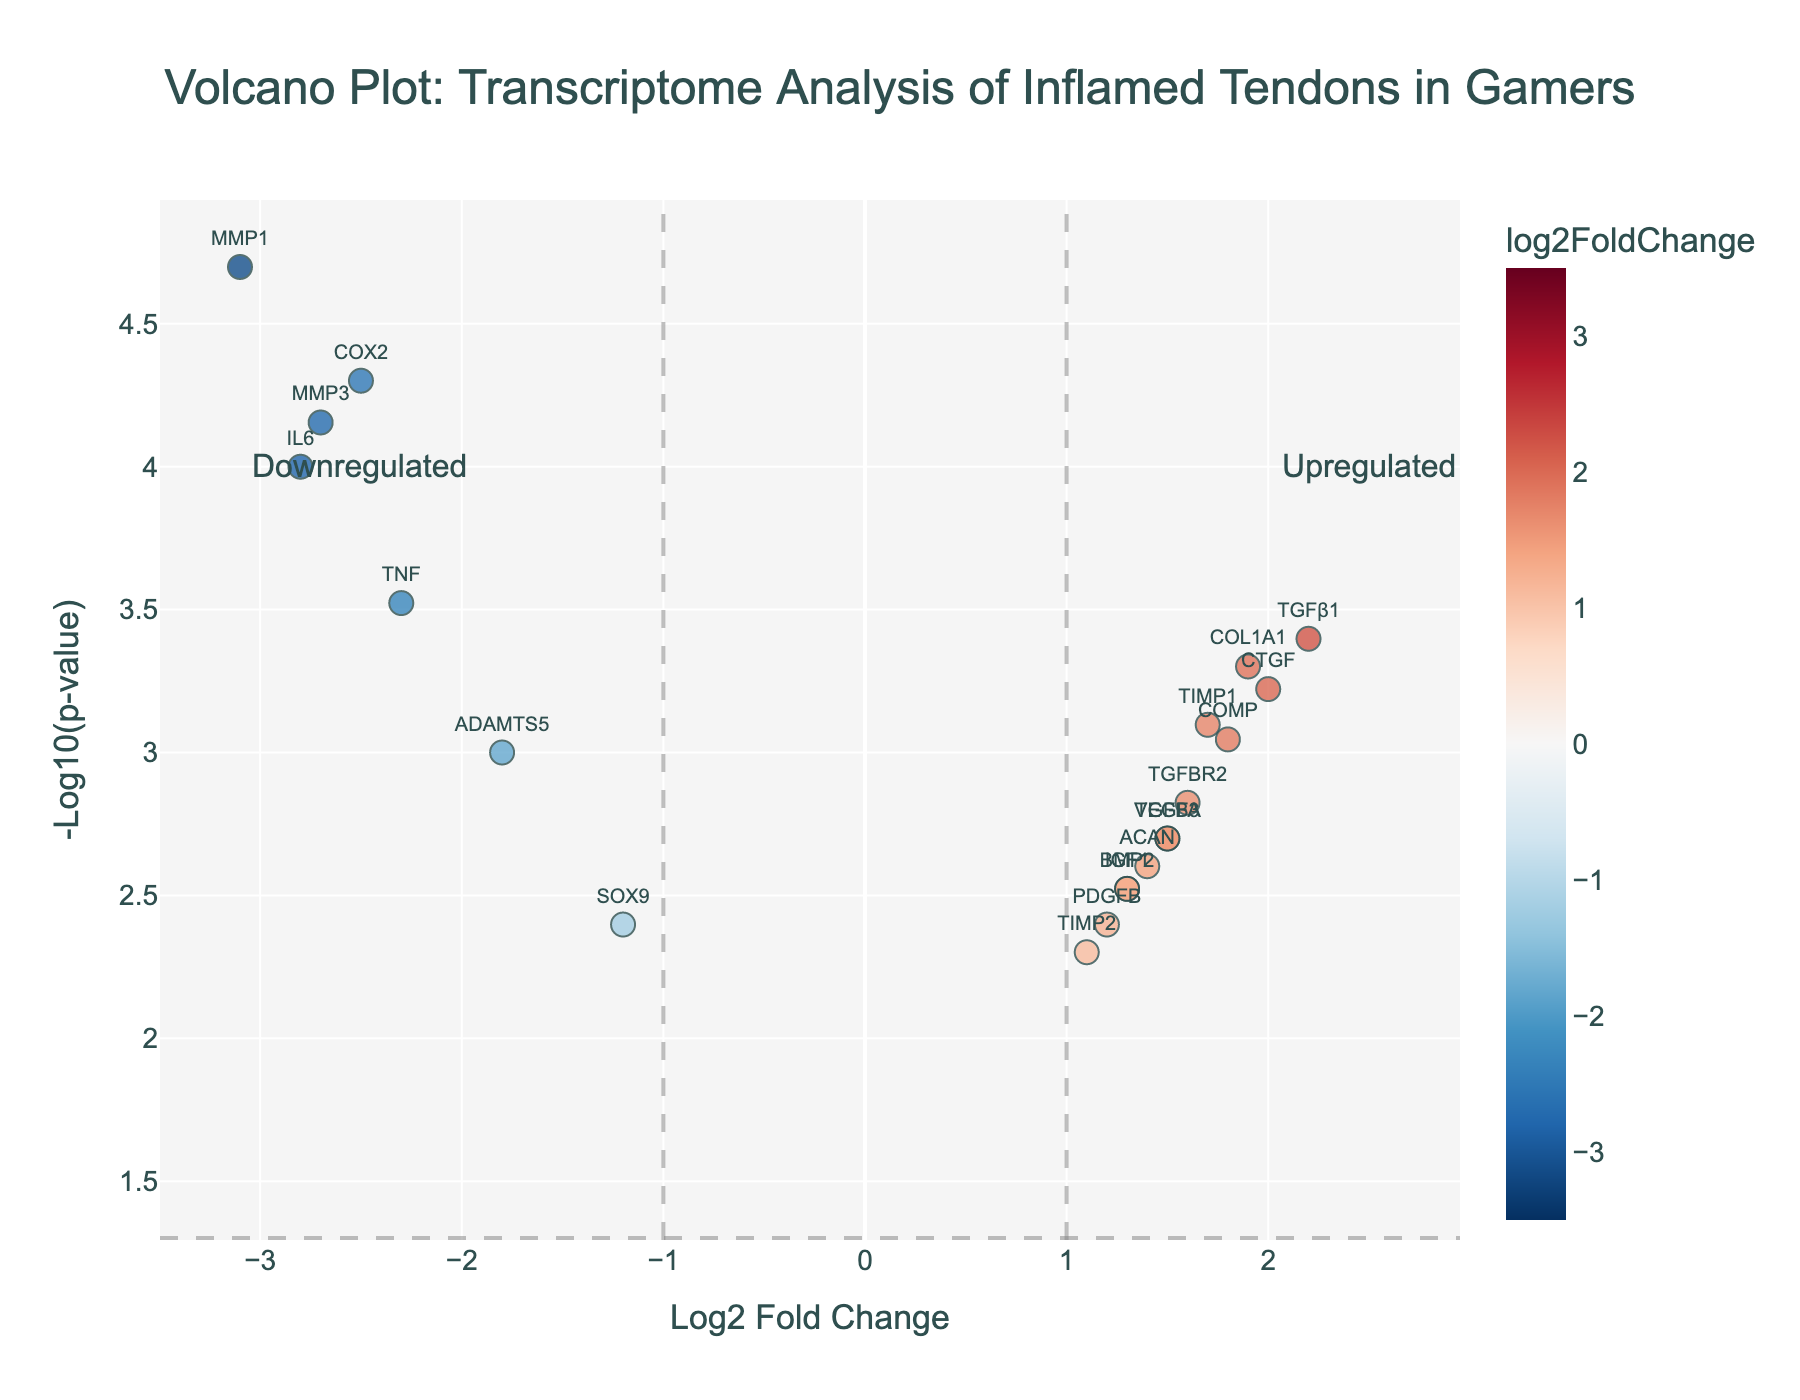What is the title of the plot? The title of the plot is usually written at the top of the figure. In this plot, the title is "Volcano Plot: Transcriptome Analysis of Inflamed Tendons in Gamers".
Answer: Volcano Plot: Transcriptome Analysis of Inflamed Tendons in Gamers Which gene has the highest -log10(p-value)? To find the gene with the highest -log10(p-value), look at the y-axis which represents -log10(p-value). The highest point on this axis is associated with the gene MMP1.
Answer: MMP1 What are the genes that are significantly upregulated? For a gene to be significantly upregulated, its log2FoldChange should be greater than 1, and its -log10(p-value) should be higher than the threshold line at y=-log10(0.05). The genes meeting this criterion are TGFβ1, CTGF, COL1A1, and TIMP1.
Answer: TGFβ1, CTGF, COL1A1, TIMP1 Which genes have a log2FoldChange of less than -2? Genes with a log2FoldChange less than -2 can be found to the left of the -2 marker on the x-axis. The genes are IL6, MMP1, COX2, MMP3.
Answer: IL6, MMP1, COX2, MMP3 What does a point's color indicate? In the plot, the color of a point indicates its log2FoldChange. Different shades represent different levels of change, with red indicating downregulation and blue indicating upregulation within a specified scale.
Answer: Log2FoldChange How many genes are downregulated with a p-value less than 0.001? To determine this, look for genes with a log2FoldChange less than 0 (downregulated) and a -log10(p-value) greater than -log10(0.001). The genes are IL6, TNF, MMP1, COX2, MMP3.
Answer: 5 What's the difference in log2FoldChange between COX2 and COL1A1? COX2 has a log2FoldChange of -2.5 and COL1A1 has a log2FoldChange of 1.9. The difference is calculated as 1.9 - (-2.5) = 4.4.
Answer: 4.4 Where is the threshold for p-value significance set in the plot? The threshold for p-value significance is shown by a horizontal dashed line at y = -log10(0.05) on the plot.
Answer: -log10(0.05) Which gene is closest to the origin (0,0)? The gene closest to (0,0) will have the smallest absolute values of log2FoldChange and -log10(p-value). The gene TIMP2 with log2FoldChange of 1.1, has the values closest to the origin.
Answer: TIMP2 How does the log2FoldChange of CTGF compare to that of TGFβ1? CTGF has a log2FoldChange of 2.0, while TGFβ1 has a log2FoldChange of 2.2. Therefore, TGFβ1 is slightly more upregulated than CTGF.
Answer: TGFβ1 > CTGF 